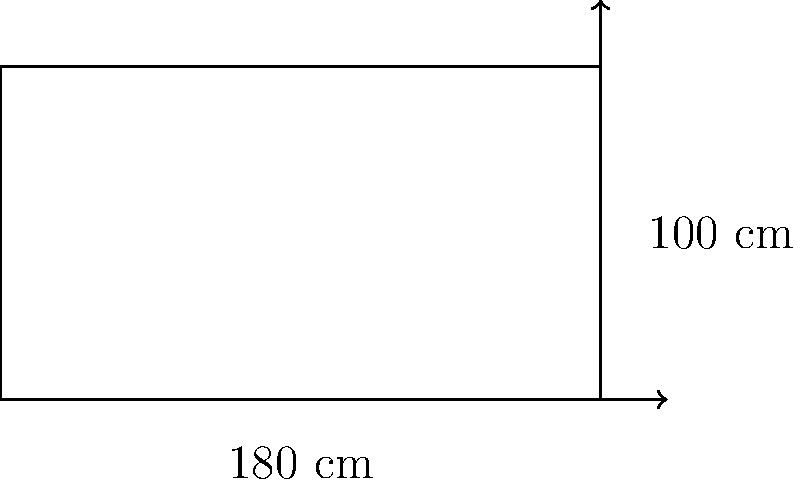As a foodie blogger in Amsterdam, you're reviewing a trendy restaurant known for its unique rectangular dining tables. The table measures 180 cm in length and 100 cm in width. What is the perimeter of this dining table? To calculate the perimeter of a rectangular table, we need to sum up the lengths of all four sides. Let's break it down step-by-step:

1. Identify the given dimensions:
   - Length (l) = 180 cm
   - Width (w) = 100 cm

2. Recall the formula for the perimeter of a rectangle:
   $$ P = 2l + 2w $$
   Where P is the perimeter, l is the length, and w is the width.

3. Substitute the values into the formula:
   $$ P = 2(180) + 2(100) $$

4. Calculate:
   $$ P = 360 + 200 = 560 $$

Therefore, the perimeter of the dining table is 560 cm.
Answer: 560 cm 